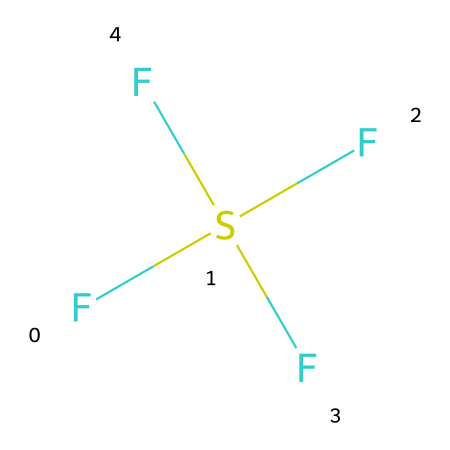What is the molecular formula of sulfur tetrafluoride? The chemical structure contains one sulfur atom and four fluorine atoms, which leads to the molecular formula SF4.
Answer: SF4 How many fluorine atoms are in the structure? By counting the number of F atoms represented, there are four fluorine atoms attached to the sulfur atom.
Answer: four What type of hybridization does sulfur exhibit in sulfur tetrafluoride? Sulfur in this structure has six electrons in its valence shell due to the four bonds with fluorine and one lone pair, indicating it employs sp3d hybridization.
Answer: sp3d What charge does the sulfur atom have in the compound? Sulfur tetrafluoride is neutral as all atoms have formed stable covalent bonds without any ionization, making the charge of sulfur zero.
Answer: zero Is sulfur tetrafluoride a polar or nonpolar molecule? The presence of four fluorine atoms creates a symmetrical arrangement; however, the overall molecular shape results in a net dipole moment, indicating that it is a polar molecule.
Answer: polar How does sulfur in this compound achieve hypervalency? Sulfur can expand its valence shell beyond the octet rule, allowing it to accommodate more than eight electrons by forming additional bonds to the four fluorine atoms.
Answer: expands valence shell What is the bond angle between the fluorine atoms in this compound? The arrangement of the four fluorine atoms around the sulfur leads to a bond angle of approximately 109.5 degrees, typical for sp3d hybridization geometries.
Answer: 109.5 degrees 